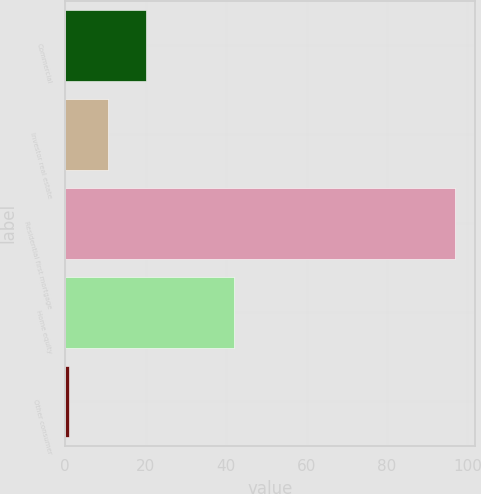<chart> <loc_0><loc_0><loc_500><loc_500><bar_chart><fcel>Commercial<fcel>Investor real estate<fcel>Residential first mortgage<fcel>Home equity<fcel>Other consumer<nl><fcel>20.2<fcel>10.6<fcel>97<fcel>42<fcel>1<nl></chart> 